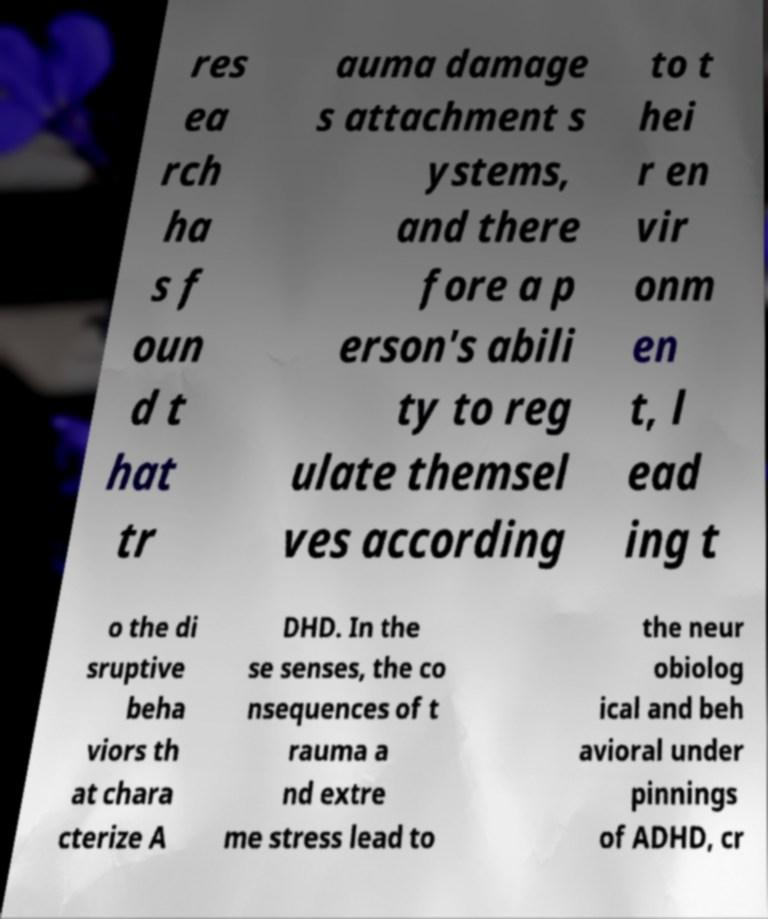Could you assist in decoding the text presented in this image and type it out clearly? res ea rch ha s f oun d t hat tr auma damage s attachment s ystems, and there fore a p erson's abili ty to reg ulate themsel ves according to t hei r en vir onm en t, l ead ing t o the di sruptive beha viors th at chara cterize A DHD. In the se senses, the co nsequences of t rauma a nd extre me stress lead to the neur obiolog ical and beh avioral under pinnings of ADHD, cr 